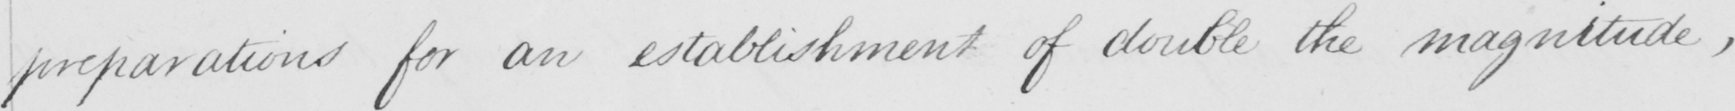What does this handwritten line say? preparations for an establishment of double the magnitude , 